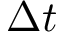<formula> <loc_0><loc_0><loc_500><loc_500>\Delta t</formula> 